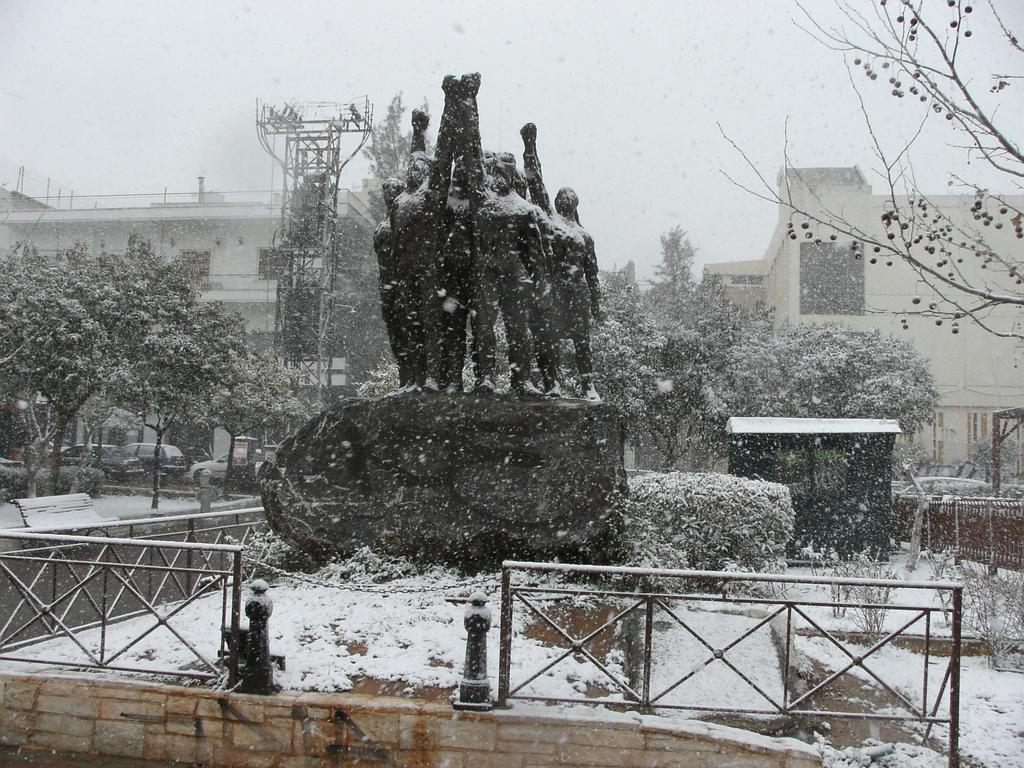What can be seen in the background of the image? There is a sky and buildings visible in the background of the image. What is the weather like in the image? The presence of snow in the image suggests that it is a snowy scene. What type of vegetation is present in the image? There are trees and plants in the image. What structures are present in the image? There are railings and a bench in the image. What artistic elements are present in the image? There are statues in the image. What man-made objects are present in the image? There are vehicles and other objects in the image. What type of appliance is being used by the credit card in the image? There is no credit card or appliance present in the image. What memory is being triggered by the snow in the image? The image does not depict any specific memories or emotions related to the snow. 